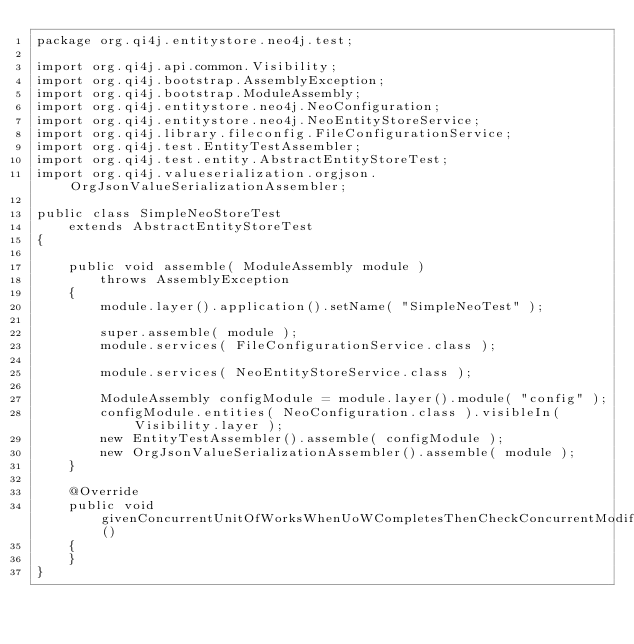<code> <loc_0><loc_0><loc_500><loc_500><_Java_>package org.qi4j.entitystore.neo4j.test;

import org.qi4j.api.common.Visibility;
import org.qi4j.bootstrap.AssemblyException;
import org.qi4j.bootstrap.ModuleAssembly;
import org.qi4j.entitystore.neo4j.NeoConfiguration;
import org.qi4j.entitystore.neo4j.NeoEntityStoreService;
import org.qi4j.library.fileconfig.FileConfigurationService;
import org.qi4j.test.EntityTestAssembler;
import org.qi4j.test.entity.AbstractEntityStoreTest;
import org.qi4j.valueserialization.orgjson.OrgJsonValueSerializationAssembler;

public class SimpleNeoStoreTest
    extends AbstractEntityStoreTest
{

    public void assemble( ModuleAssembly module )
        throws AssemblyException
    {
        module.layer().application().setName( "SimpleNeoTest" );

        super.assemble( module );
        module.services( FileConfigurationService.class );

        module.services( NeoEntityStoreService.class );

        ModuleAssembly configModule = module.layer().module( "config" );
        configModule.entities( NeoConfiguration.class ).visibleIn( Visibility.layer );
        new EntityTestAssembler().assemble( configModule );
        new OrgJsonValueSerializationAssembler().assemble( module );
    }

    @Override
    public void givenConcurrentUnitOfWorksWhenUoWCompletesThenCheckConcurrentModification()
    {
    }
}
</code> 